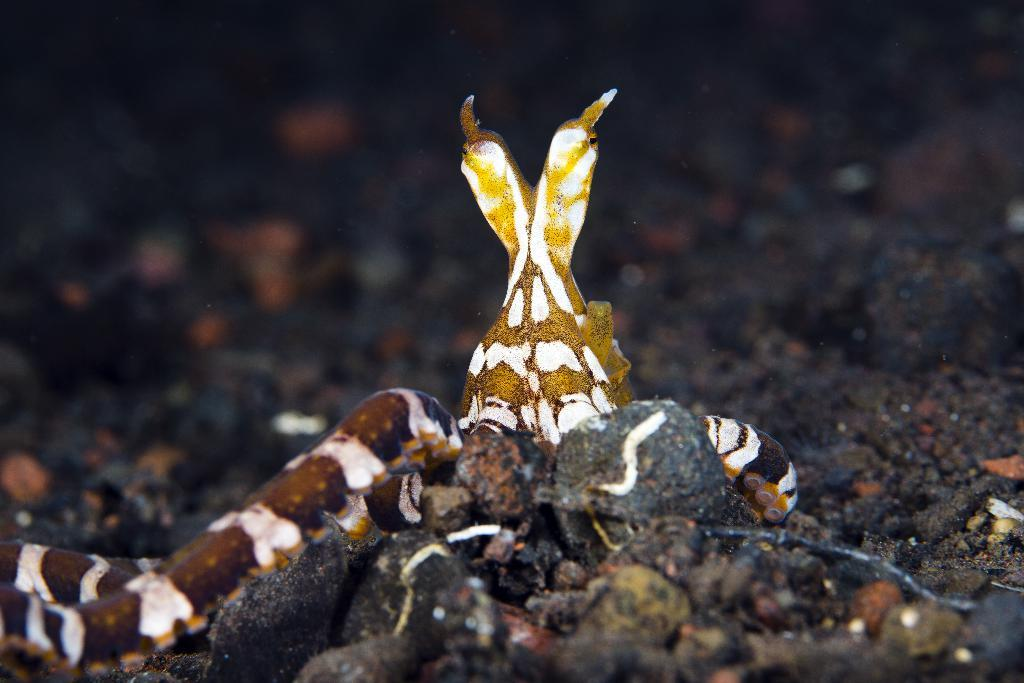What type of animal is depicted in the image? There is a double-headed snake in the image. What else can be seen in the image besides the snake? There are stones visible in the image. What is the ground made of in the image? Soil is present in the image. What type of soda is being poured into the snake's mouth in the image? There is no soda present in the image; it features a double-headed snake and stones on soil. 